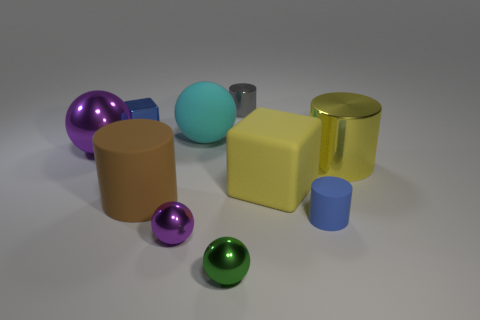Are the big brown object and the small blue block made of the same material?
Provide a succinct answer. No. How many small things are both behind the big rubber block and to the left of the tiny green object?
Your response must be concise. 1. How many other things are the same color as the big metallic cylinder?
Keep it short and to the point. 1. What number of blue objects are large blocks or metallic cubes?
Your answer should be very brief. 1. What is the size of the shiny cube?
Your answer should be very brief. Small. What number of matte objects are either brown objects or small blue things?
Provide a succinct answer. 2. Are there fewer large spheres than big brown blocks?
Your answer should be very brief. No. What number of other things are there of the same material as the blue block
Offer a terse response. 5. There is a cyan rubber object that is the same shape as the green thing; what size is it?
Provide a short and direct response. Large. Does the purple ball that is left of the large rubber cylinder have the same material as the small blue thing in front of the large brown cylinder?
Provide a succinct answer. No. 